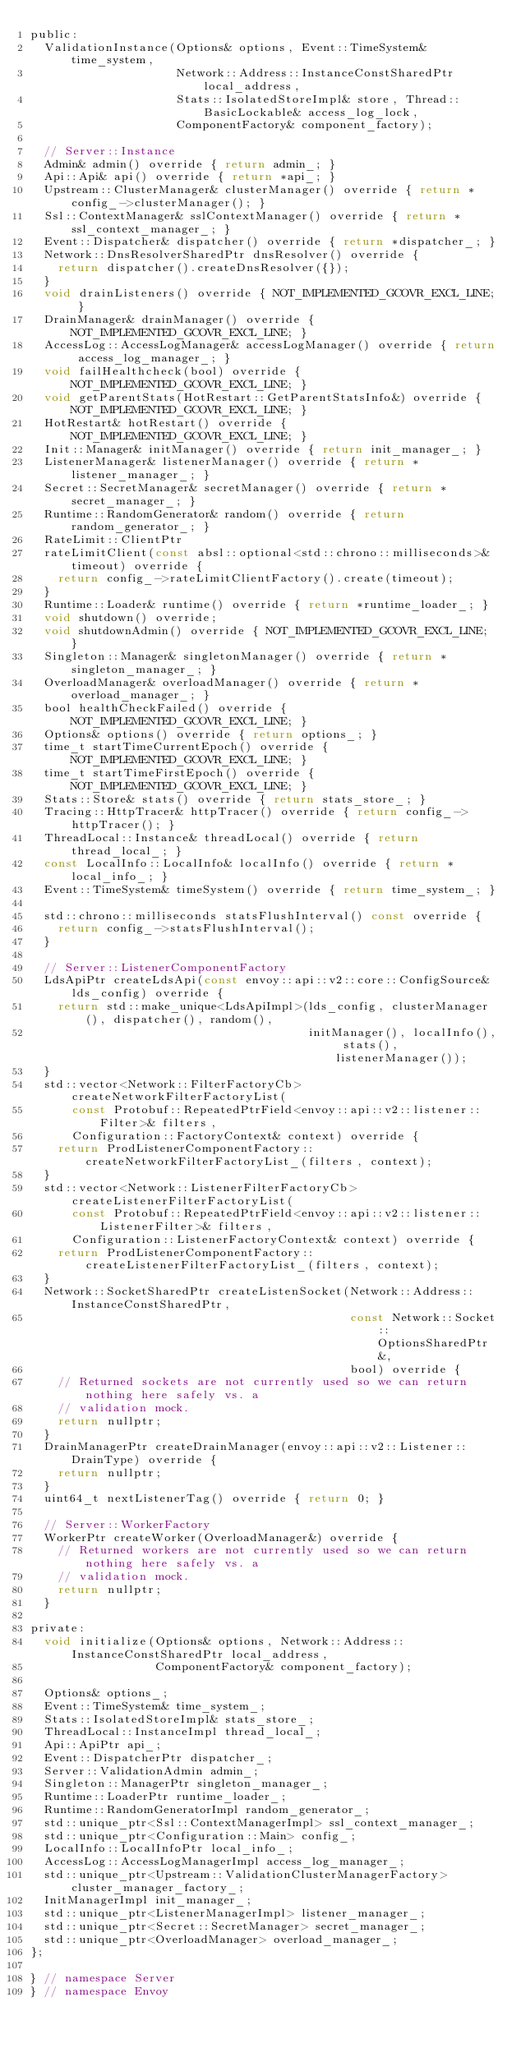Convert code to text. <code><loc_0><loc_0><loc_500><loc_500><_C_>public:
  ValidationInstance(Options& options, Event::TimeSystem& time_system,
                     Network::Address::InstanceConstSharedPtr local_address,
                     Stats::IsolatedStoreImpl& store, Thread::BasicLockable& access_log_lock,
                     ComponentFactory& component_factory);

  // Server::Instance
  Admin& admin() override { return admin_; }
  Api::Api& api() override { return *api_; }
  Upstream::ClusterManager& clusterManager() override { return *config_->clusterManager(); }
  Ssl::ContextManager& sslContextManager() override { return *ssl_context_manager_; }
  Event::Dispatcher& dispatcher() override { return *dispatcher_; }
  Network::DnsResolverSharedPtr dnsResolver() override {
    return dispatcher().createDnsResolver({});
  }
  void drainListeners() override { NOT_IMPLEMENTED_GCOVR_EXCL_LINE; }
  DrainManager& drainManager() override { NOT_IMPLEMENTED_GCOVR_EXCL_LINE; }
  AccessLog::AccessLogManager& accessLogManager() override { return access_log_manager_; }
  void failHealthcheck(bool) override { NOT_IMPLEMENTED_GCOVR_EXCL_LINE; }
  void getParentStats(HotRestart::GetParentStatsInfo&) override { NOT_IMPLEMENTED_GCOVR_EXCL_LINE; }
  HotRestart& hotRestart() override { NOT_IMPLEMENTED_GCOVR_EXCL_LINE; }
  Init::Manager& initManager() override { return init_manager_; }
  ListenerManager& listenerManager() override { return *listener_manager_; }
  Secret::SecretManager& secretManager() override { return *secret_manager_; }
  Runtime::RandomGenerator& random() override { return random_generator_; }
  RateLimit::ClientPtr
  rateLimitClient(const absl::optional<std::chrono::milliseconds>& timeout) override {
    return config_->rateLimitClientFactory().create(timeout);
  }
  Runtime::Loader& runtime() override { return *runtime_loader_; }
  void shutdown() override;
  void shutdownAdmin() override { NOT_IMPLEMENTED_GCOVR_EXCL_LINE; }
  Singleton::Manager& singletonManager() override { return *singleton_manager_; }
  OverloadManager& overloadManager() override { return *overload_manager_; }
  bool healthCheckFailed() override { NOT_IMPLEMENTED_GCOVR_EXCL_LINE; }
  Options& options() override { return options_; }
  time_t startTimeCurrentEpoch() override { NOT_IMPLEMENTED_GCOVR_EXCL_LINE; }
  time_t startTimeFirstEpoch() override { NOT_IMPLEMENTED_GCOVR_EXCL_LINE; }
  Stats::Store& stats() override { return stats_store_; }
  Tracing::HttpTracer& httpTracer() override { return config_->httpTracer(); }
  ThreadLocal::Instance& threadLocal() override { return thread_local_; }
  const LocalInfo::LocalInfo& localInfo() override { return *local_info_; }
  Event::TimeSystem& timeSystem() override { return time_system_; }

  std::chrono::milliseconds statsFlushInterval() const override {
    return config_->statsFlushInterval();
  }

  // Server::ListenerComponentFactory
  LdsApiPtr createLdsApi(const envoy::api::v2::core::ConfigSource& lds_config) override {
    return std::make_unique<LdsApiImpl>(lds_config, clusterManager(), dispatcher(), random(),
                                        initManager(), localInfo(), stats(), listenerManager());
  }
  std::vector<Network::FilterFactoryCb> createNetworkFilterFactoryList(
      const Protobuf::RepeatedPtrField<envoy::api::v2::listener::Filter>& filters,
      Configuration::FactoryContext& context) override {
    return ProdListenerComponentFactory::createNetworkFilterFactoryList_(filters, context);
  }
  std::vector<Network::ListenerFilterFactoryCb> createListenerFilterFactoryList(
      const Protobuf::RepeatedPtrField<envoy::api::v2::listener::ListenerFilter>& filters,
      Configuration::ListenerFactoryContext& context) override {
    return ProdListenerComponentFactory::createListenerFilterFactoryList_(filters, context);
  }
  Network::SocketSharedPtr createListenSocket(Network::Address::InstanceConstSharedPtr,
                                              const Network::Socket::OptionsSharedPtr&,
                                              bool) override {
    // Returned sockets are not currently used so we can return nothing here safely vs. a
    // validation mock.
    return nullptr;
  }
  DrainManagerPtr createDrainManager(envoy::api::v2::Listener::DrainType) override {
    return nullptr;
  }
  uint64_t nextListenerTag() override { return 0; }

  // Server::WorkerFactory
  WorkerPtr createWorker(OverloadManager&) override {
    // Returned workers are not currently used so we can return nothing here safely vs. a
    // validation mock.
    return nullptr;
  }

private:
  void initialize(Options& options, Network::Address::InstanceConstSharedPtr local_address,
                  ComponentFactory& component_factory);

  Options& options_;
  Event::TimeSystem& time_system_;
  Stats::IsolatedStoreImpl& stats_store_;
  ThreadLocal::InstanceImpl thread_local_;
  Api::ApiPtr api_;
  Event::DispatcherPtr dispatcher_;
  Server::ValidationAdmin admin_;
  Singleton::ManagerPtr singleton_manager_;
  Runtime::LoaderPtr runtime_loader_;
  Runtime::RandomGeneratorImpl random_generator_;
  std::unique_ptr<Ssl::ContextManagerImpl> ssl_context_manager_;
  std::unique_ptr<Configuration::Main> config_;
  LocalInfo::LocalInfoPtr local_info_;
  AccessLog::AccessLogManagerImpl access_log_manager_;
  std::unique_ptr<Upstream::ValidationClusterManagerFactory> cluster_manager_factory_;
  InitManagerImpl init_manager_;
  std::unique_ptr<ListenerManagerImpl> listener_manager_;
  std::unique_ptr<Secret::SecretManager> secret_manager_;
  std::unique_ptr<OverloadManager> overload_manager_;
};

} // namespace Server
} // namespace Envoy
</code> 